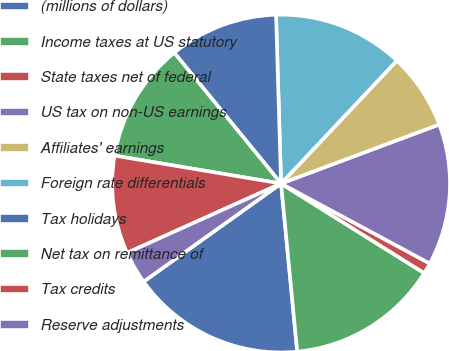Convert chart. <chart><loc_0><loc_0><loc_500><loc_500><pie_chart><fcel>(millions of dollars)<fcel>Income taxes at US statutory<fcel>State taxes net of federal<fcel>US tax on non-US earnings<fcel>Affiliates' earnings<fcel>Foreign rate differentials<fcel>Tax holidays<fcel>Net tax on remittance of<fcel>Tax credits<fcel>Reserve adjustments<nl><fcel>16.66%<fcel>14.58%<fcel>1.05%<fcel>13.54%<fcel>7.29%<fcel>12.5%<fcel>10.42%<fcel>11.46%<fcel>9.38%<fcel>3.13%<nl></chart> 